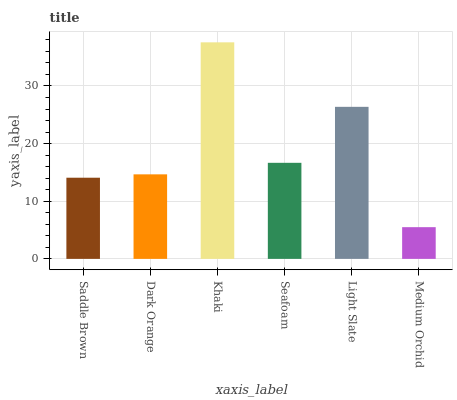Is Dark Orange the minimum?
Answer yes or no. No. Is Dark Orange the maximum?
Answer yes or no. No. Is Dark Orange greater than Saddle Brown?
Answer yes or no. Yes. Is Saddle Brown less than Dark Orange?
Answer yes or no. Yes. Is Saddle Brown greater than Dark Orange?
Answer yes or no. No. Is Dark Orange less than Saddle Brown?
Answer yes or no. No. Is Seafoam the high median?
Answer yes or no. Yes. Is Dark Orange the low median?
Answer yes or no. Yes. Is Saddle Brown the high median?
Answer yes or no. No. Is Khaki the low median?
Answer yes or no. No. 